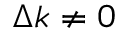Convert formula to latex. <formula><loc_0><loc_0><loc_500><loc_500>\Delta k \neq 0</formula> 